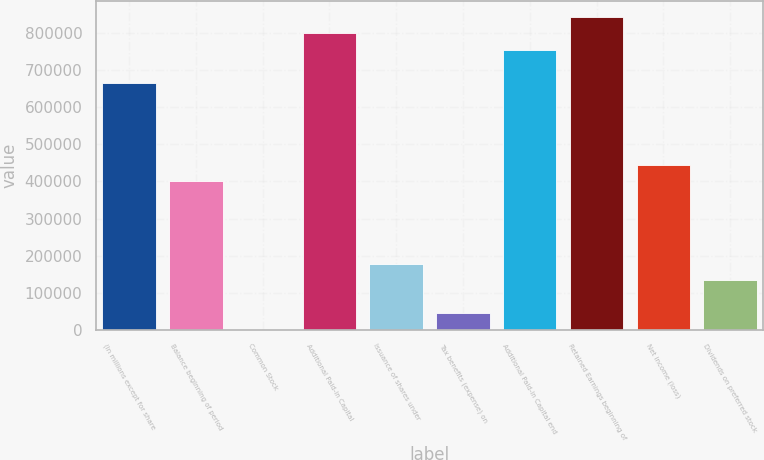<chart> <loc_0><loc_0><loc_500><loc_500><bar_chart><fcel>(In millions except for share<fcel>Balance beginning of period<fcel>Common Stock<fcel>Additional Paid-in Capital<fcel>Issuance of shares under<fcel>Tax benefits (expense) on<fcel>Additional Paid-in Capital end<fcel>Retained Earnings beginning of<fcel>Net income (loss)<fcel>Dividends on preferred stock<nl><fcel>666821<fcel>400095<fcel>5<fcel>800184<fcel>177823<fcel>44459.4<fcel>755730<fcel>844639<fcel>444549<fcel>133368<nl></chart> 